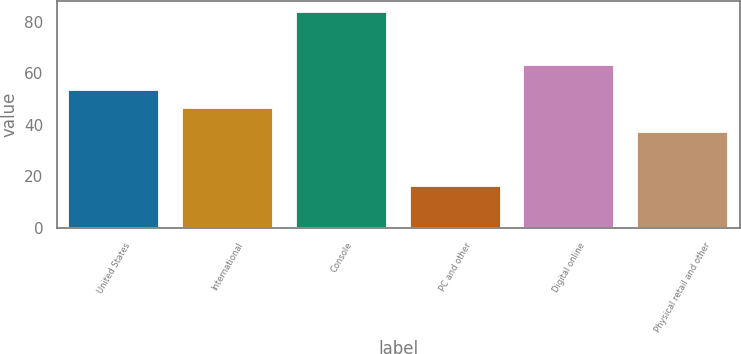Convert chart to OTSL. <chart><loc_0><loc_0><loc_500><loc_500><bar_chart><fcel>United States<fcel>International<fcel>Console<fcel>PC and other<fcel>Digital online<fcel>Physical retail and other<nl><fcel>53.5<fcel>46.5<fcel>83.7<fcel>16.3<fcel>63<fcel>37<nl></chart> 